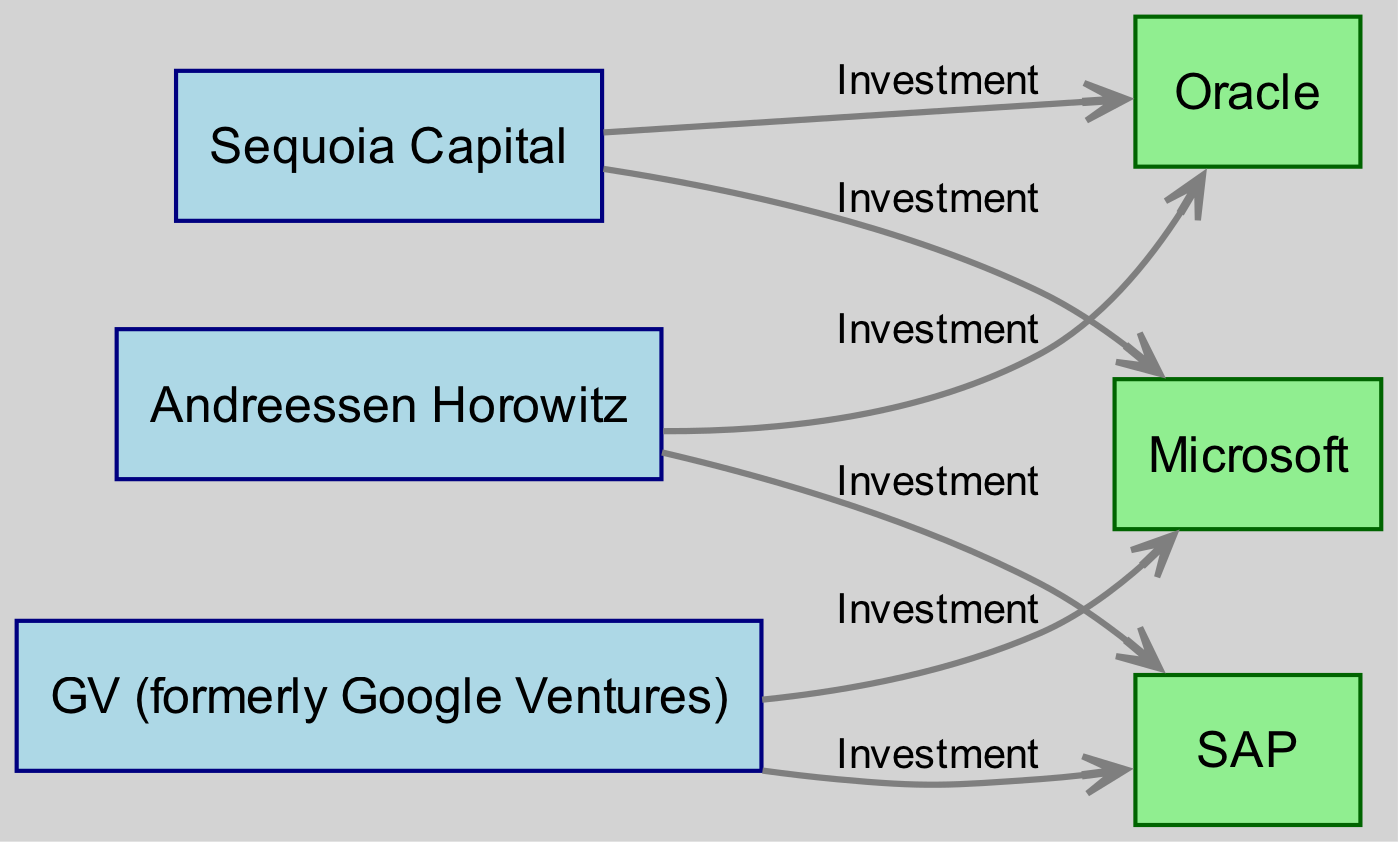What are the total number of nodes in the diagram? The diagram includes 6 distinct nodes: 3 tech investors and 3 closed-source software companies. By counting each of them separately, we identify that there are a total of 6 nodes.
Answer: 6 Which company receives investments from Sequoia Capital? In the diagram, an edge labeled "Investment" from Sequoia Capital points to Microsoft and Oracle, indicating both companies receive investments from this tech investor.
Answer: Microsoft, Oracle How many investments does Oracle receive from tech investors? By examining the edges connecting to Oracle, there are two edges leading to Oracle from the investors (Sequoia Capital and Andreessen Horowitz), indicating that Oracle receives a total of 2 investments.
Answer: 2 Which investor has the most connections in this diagram? By analyzing the connections (edges) of each investor, Sequoia Capital has 2 connections (to Microsoft and Oracle), Andreessen Horowitz has 2 connections (to Oracle and SAP), and GV has 2 connections (to Microsoft and SAP). Each investor has the same number of connections, so no single investor has more.
Answer: None Which closed-source software company is linked with the highest number of tech investors? Oracle is connected to both Sequoia Capital and Andreessen Horowitz, making it the closed-source software company with the highest number of connections (2). Microsoft and SAP each have 2 connections with different investors, but Oracle has connections to different investors.
Answer: Oracle How many total investments are represented in the diagram? By counting the edges in the diagram, we find that there are a total of 6 investments represented, as each edge is labeled as an investment and connects an investor with a closed-source software company specifically.
Answer: 6 Is there any overlap of investment between investors for the same closed-source software company? Yes, both Sequoia Capital and GV invest in Microsoft, illustrating that there is an overlap in investments as multiple investors are providing funds to the same closed-source software entity.
Answer: Yes Which tech investor connects to SAP? Analyzing the edges reveals that Andreessen Horowitz and GV connect to SAP, showing that both tech investors choose to invest in this closed-source software company.
Answer: Andreessen Horowitz, GV How many edges are connecting from tech investors to closed-source software companies? The total number of edges is counted to determine the investment connections between tech investors and closed-source software companies, which is established by reviewing each directed edge in the diagram. There are 6 edges in total.
Answer: 6 